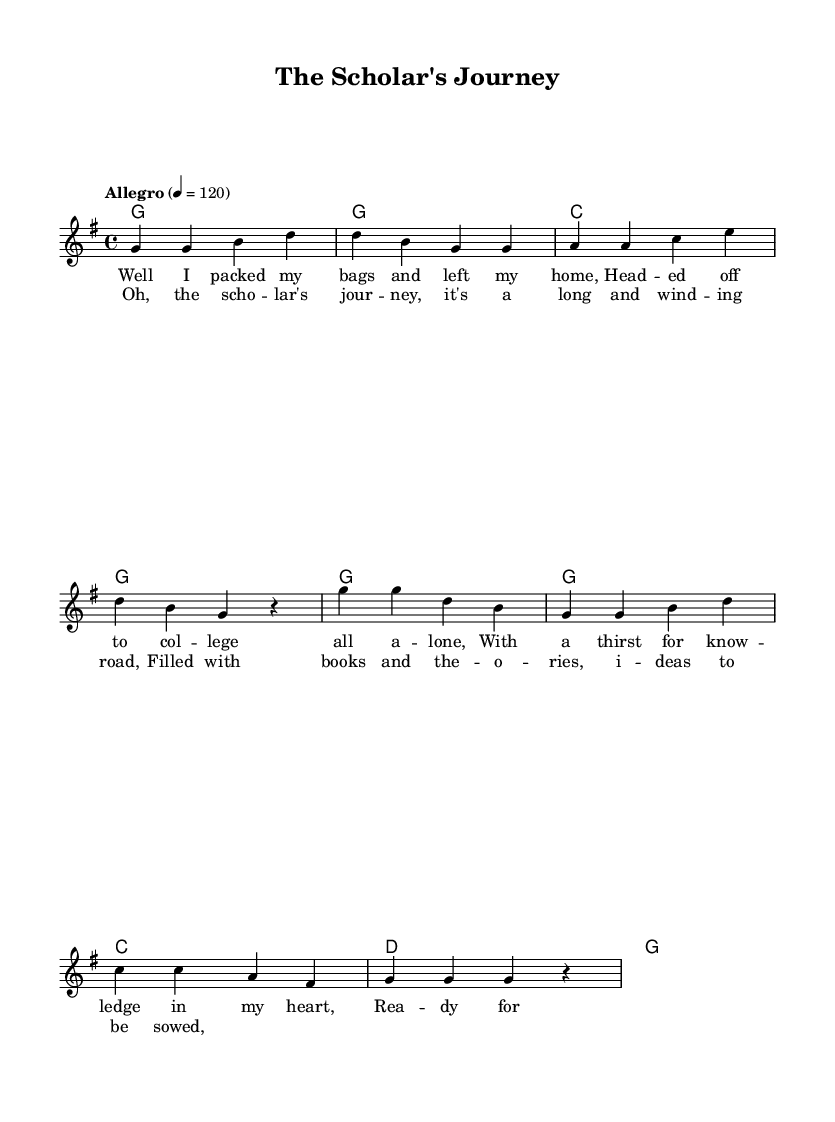What is the key signature of this music? The key signature is G major, which has one sharp note (F#). This can be identified by looking at the key signature indicated at the beginning of the staff.
Answer: G major What is the time signature of this music? The time signature is 4/4, meaning there are four beats in each measure and a quarter note receives one beat. This is indicated at the beginning of the piece.
Answer: 4/4 What is the tempo marking for this piece? The tempo marking indicates "Allegro," which generally means a fast, lively pace. This is specified at the beginning, stating the beats per minute as 120.
Answer: Allegro How many measures are in the verse? The verse consists of four measures, as counted from the notation provided for the melody. The separation of the phrases in the measure shows this clearly.
Answer: Four What is the primary theme of the lyrics in this song? The primary theme revolves around academic pursuits and intellectual growth, evidenced by the lyrics discussing going to college and a thirst for knowledge. Analyzing the content of the lyrics confirms this central idea.
Answer: Academic pursuits Which chords are used in the chorus? The chorus utilizes the chords G, C, and D, as outlined in the chord mode section. Each chord is noted with a corresponding measure to display where they fit within the musical structure.
Answer: G, C, D How does the melody in the chorus compare to the verse? The melody in the chorus starts higher than the verse and has a more repetitive structure, creating a contrast in energy and feel. Analyzing the note pitches and rhythmic patterns helps identify this comparison.
Answer: Higher and repetitive 